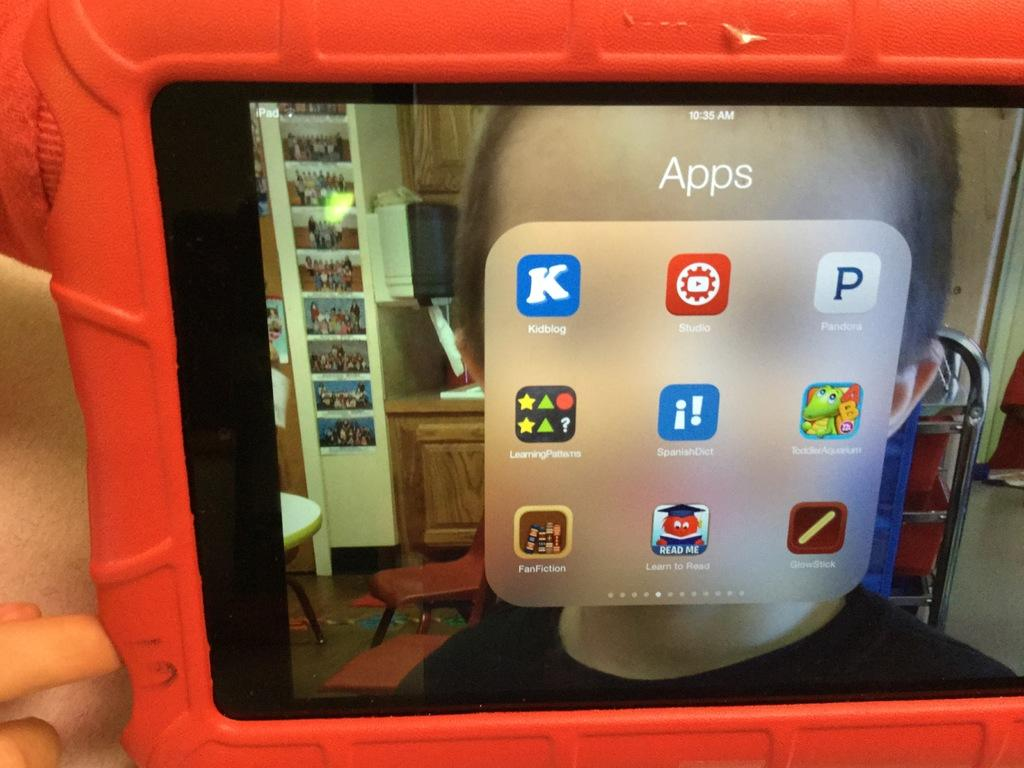Provide a one-sentence caption for the provided image. iPAD showing different apps with "Kidblog" being the first. 